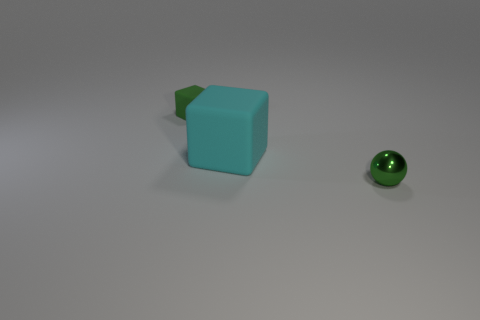What is the object that is on the right side of the matte cube that is in front of the tiny green block made of?
Provide a succinct answer. Metal. Do the big cyan thing and the small matte object that is left of the large rubber cube have the same shape?
Provide a short and direct response. Yes. How many shiny things are blocks or big objects?
Provide a succinct answer. 0. The block that is to the right of the small green thing that is on the left side of the tiny green object that is on the right side of the small matte cube is what color?
Your answer should be very brief. Cyan. How many other things are the same material as the sphere?
Make the answer very short. 0. There is a tiny green thing that is behind the small sphere; does it have the same shape as the large cyan matte thing?
Make the answer very short. Yes. How many large objects are gray metallic cylinders or green shiny spheres?
Ensure brevity in your answer.  0. Are there the same number of cyan rubber objects behind the small green matte thing and rubber objects that are to the left of the big thing?
Make the answer very short. No. How many other objects are there of the same color as the metal sphere?
Make the answer very short. 1. Do the shiny object and the matte thing behind the cyan matte object have the same color?
Your response must be concise. Yes. 